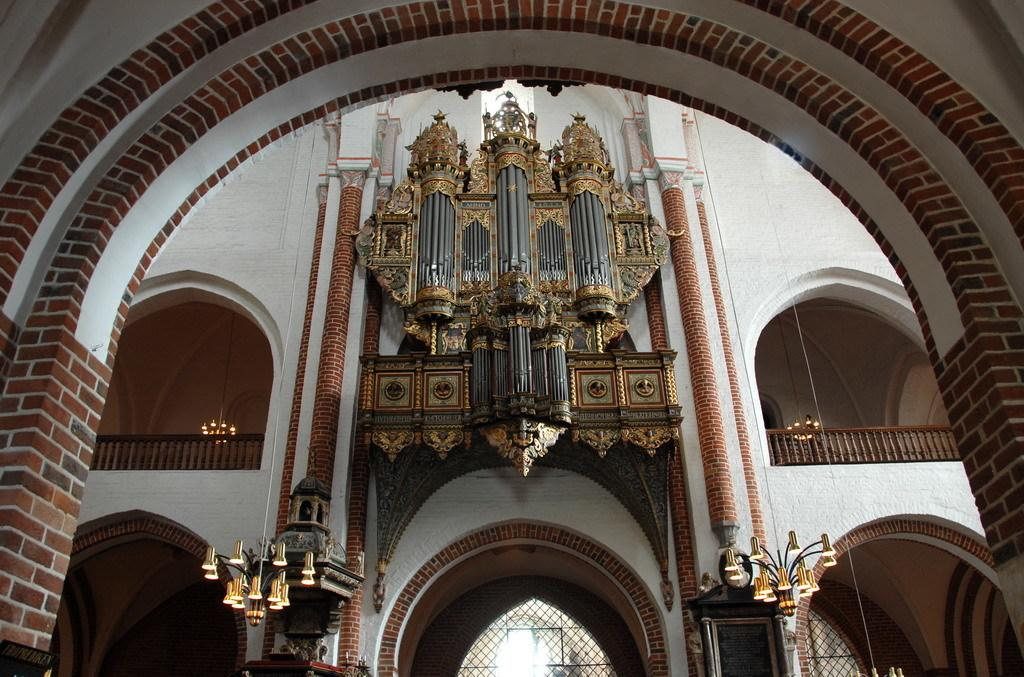What type of structures are present in the image? There are buildings in the image. What features can be seen on the buildings? The buildings have lamps and balconies. What is located in the front of the image? There is a wall in the front of the image. What type of thread is being used to hold the circle in the image? There is no circle or thread present in the image. 